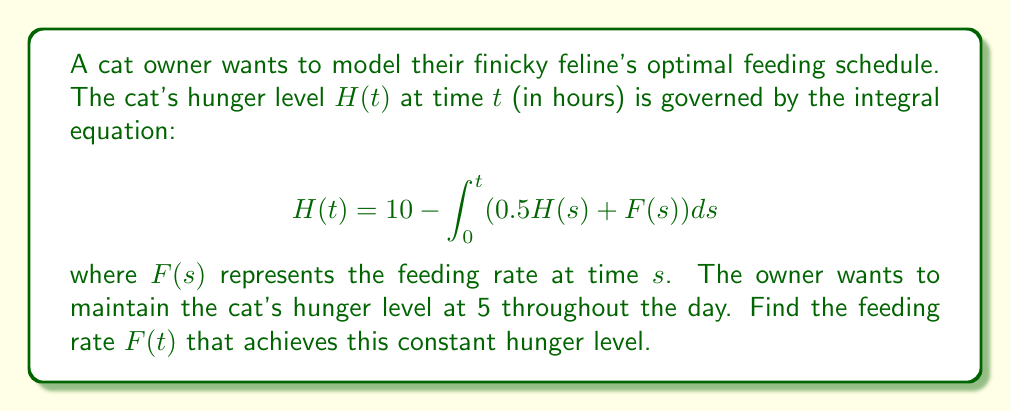Show me your answer to this math problem. Let's solve this step-by-step:

1) We want $H(t) = 5$ for all $t$. Substituting this into the equation:

   $$5 = 10 - \int_0^t (0.5 \cdot 5 + F(s))ds$$

2) Simplify the left side of the equation:

   $$5 = 10 - \int_0^t (2.5 + F(s))ds$$

3) Subtract 5 from both sides:

   $$0 = 5 - \int_0^t (2.5 + F(s))ds$$

4) Differentiate both sides with respect to $t$:

   $$0 = -2.5 - F(t)$$

5) Solve for $F(t)$:

   $$F(t) = -2.5$$

6) Therefore, the feeding rate should be constant at 2.5 units per hour to maintain the cat's hunger level at 5.
Answer: $F(t) = 2.5$ 